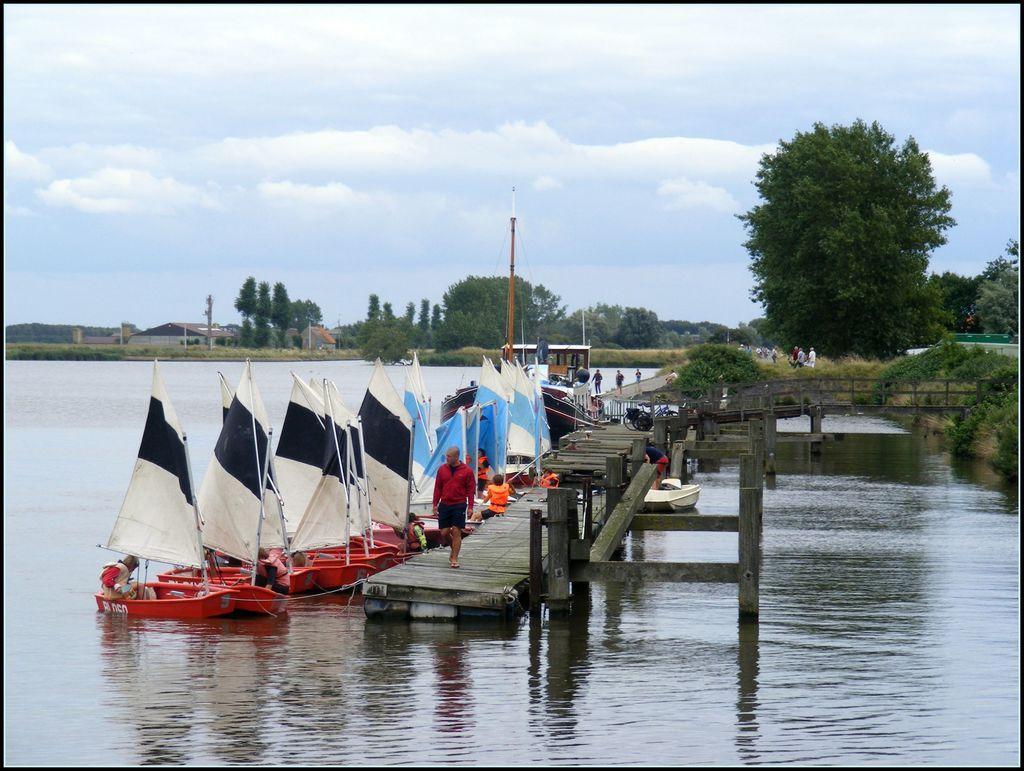How would you summarize this image in a sentence or two? This image is taken outdoors. At the top of the image there is the sky with clouds. At the bottom of the image there is a pond with water. In the background there are many trees and plants. There are a few houses. There are a few poles. A few people are standing on the ground. On the right side of the image there is a bridge with walls and pillars. There are a few plants and trees. In the middle of the image there is a wooden platform. There are many boats in the pond. There are many flags. There are a few people sitting in the boats and a man is walking on the platform. 